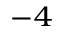Convert formula to latex. <formula><loc_0><loc_0><loc_500><loc_500>^ { - 4 }</formula> 